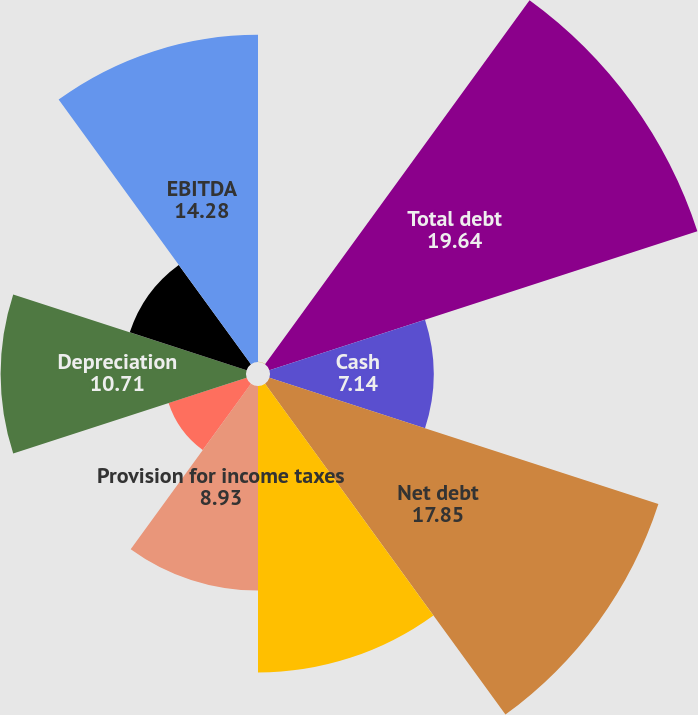Convert chart to OTSL. <chart><loc_0><loc_0><loc_500><loc_500><pie_chart><fcel>Net debt to EBITDA<fcel>Total debt<fcel>Cash<fcel>Net debt<fcel>Net income including<fcel>Provision for income taxes<fcel>Interest expense net<fcel>Depreciation<fcel>Amortization<fcel>EBITDA<nl><fcel>0.01%<fcel>19.64%<fcel>7.14%<fcel>17.85%<fcel>12.5%<fcel>8.93%<fcel>3.58%<fcel>10.71%<fcel>5.36%<fcel>14.28%<nl></chart> 